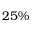<formula> <loc_0><loc_0><loc_500><loc_500>2 5 \%</formula> 